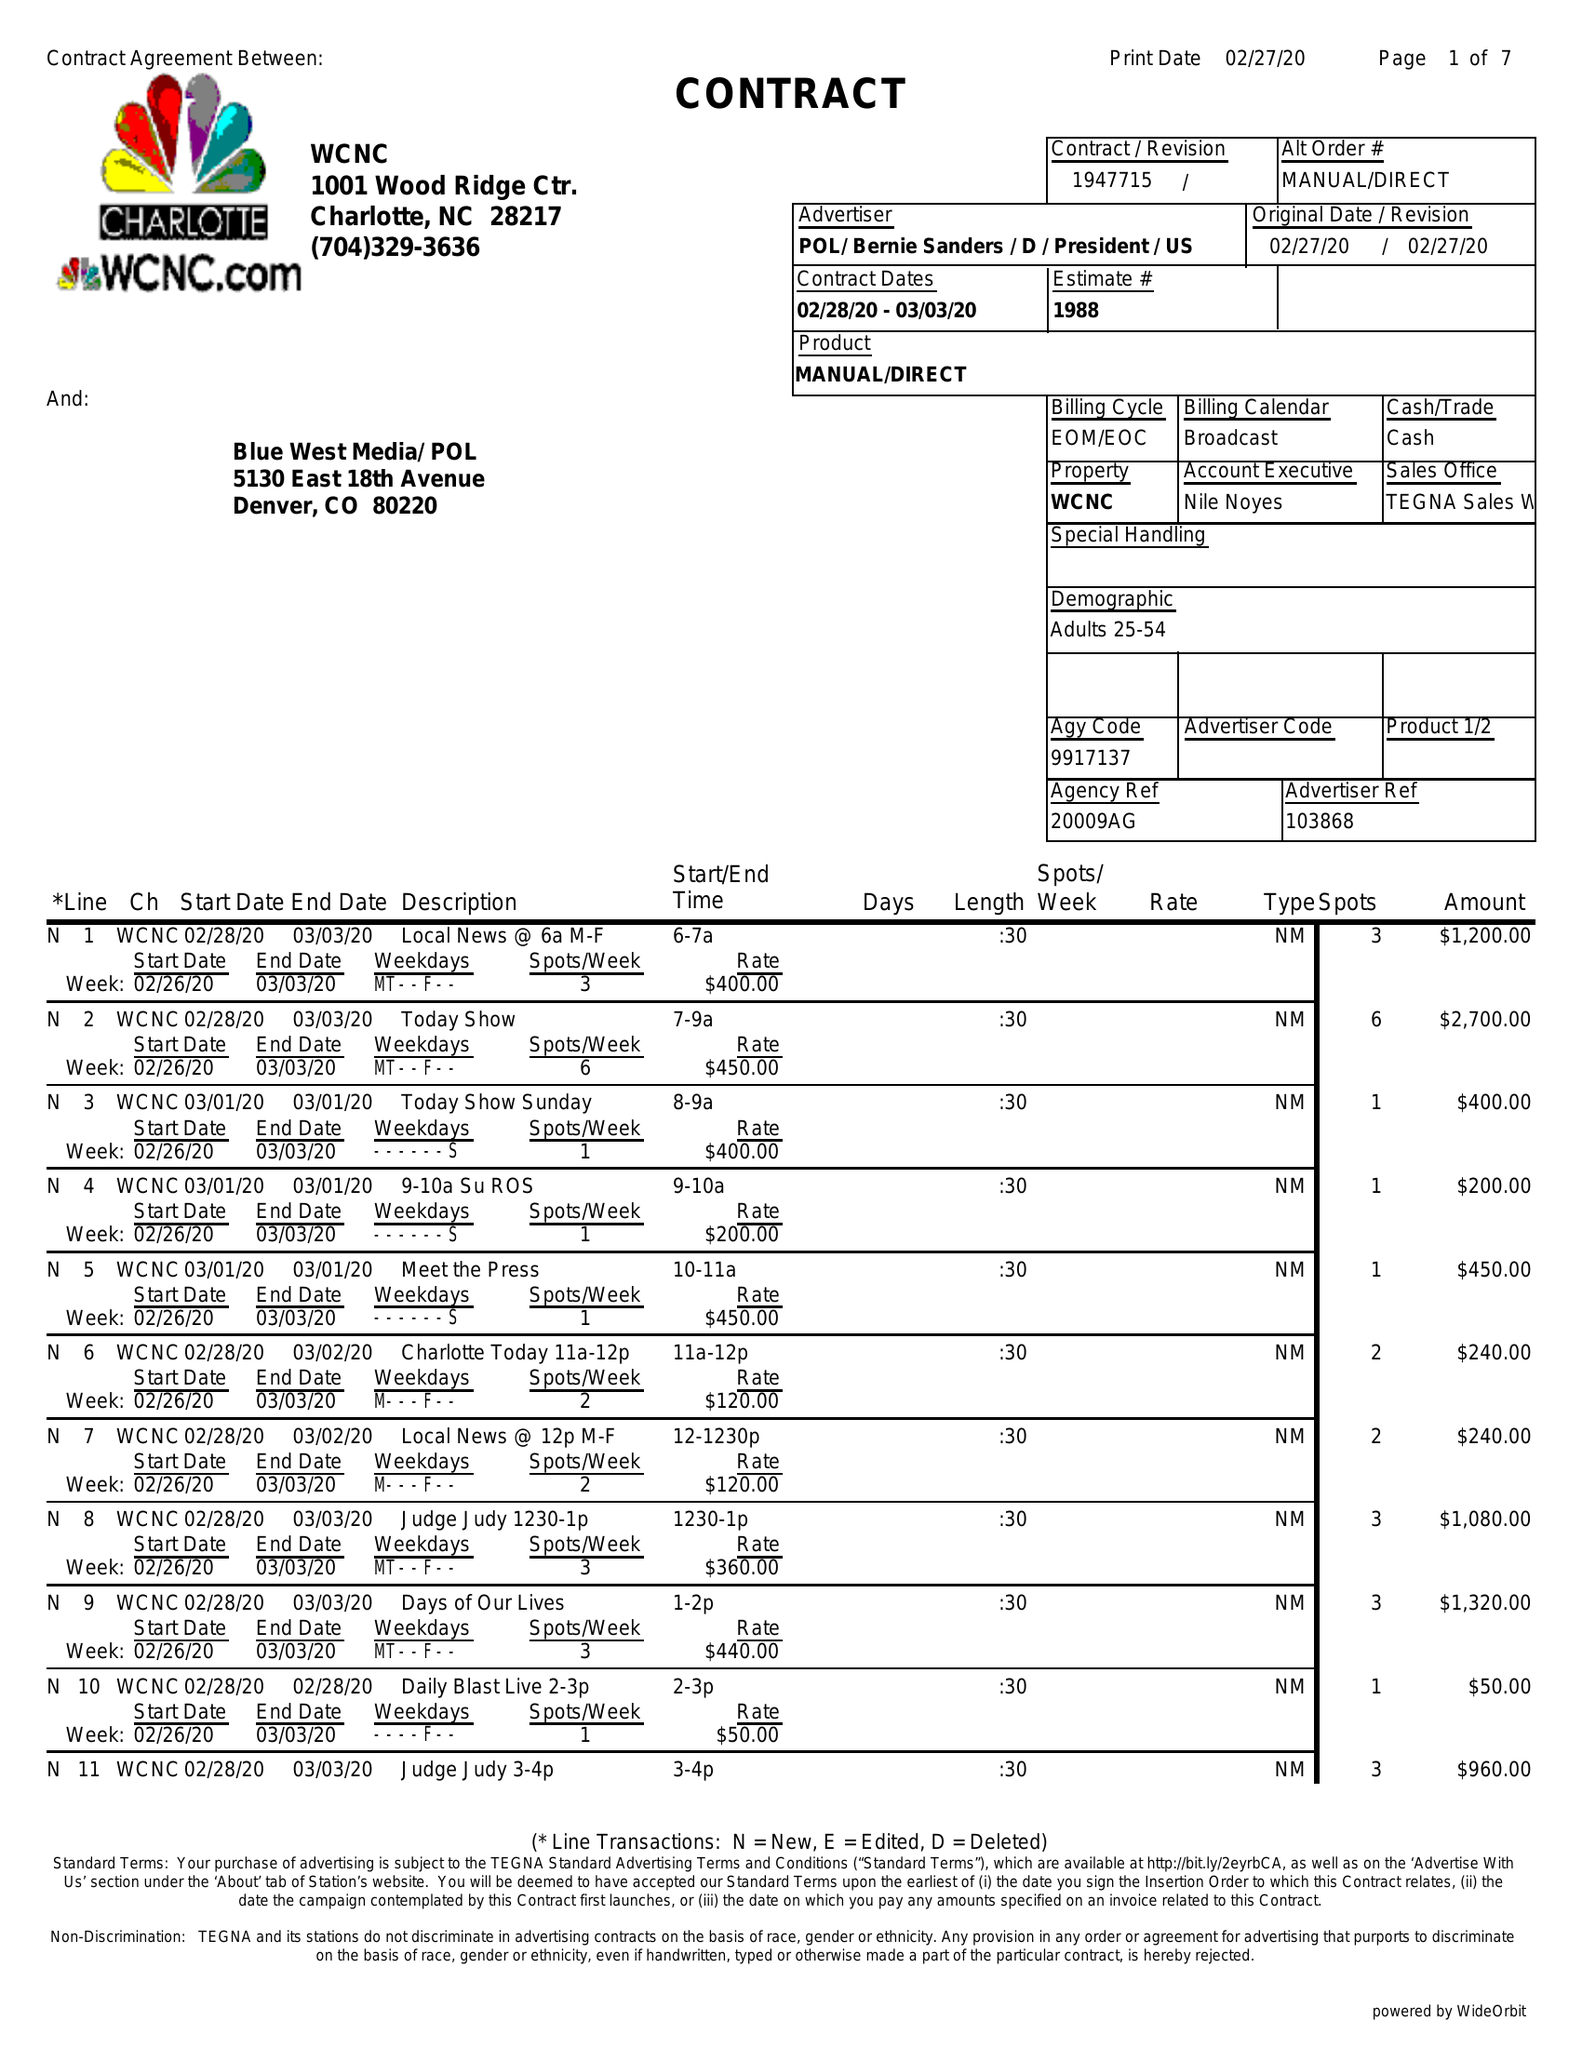What is the value for the advertiser?
Answer the question using a single word or phrase. POL/BERNIESANDERS/D/PRESIDENT/US 